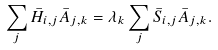Convert formula to latex. <formula><loc_0><loc_0><loc_500><loc_500>\sum _ { j } { \bar { H } } _ { i , j } { \bar { A } } _ { j , k } = \lambda _ { k } \sum _ { j } { \bar { S } } _ { i , j } { \bar { A } } _ { j , k } .</formula> 